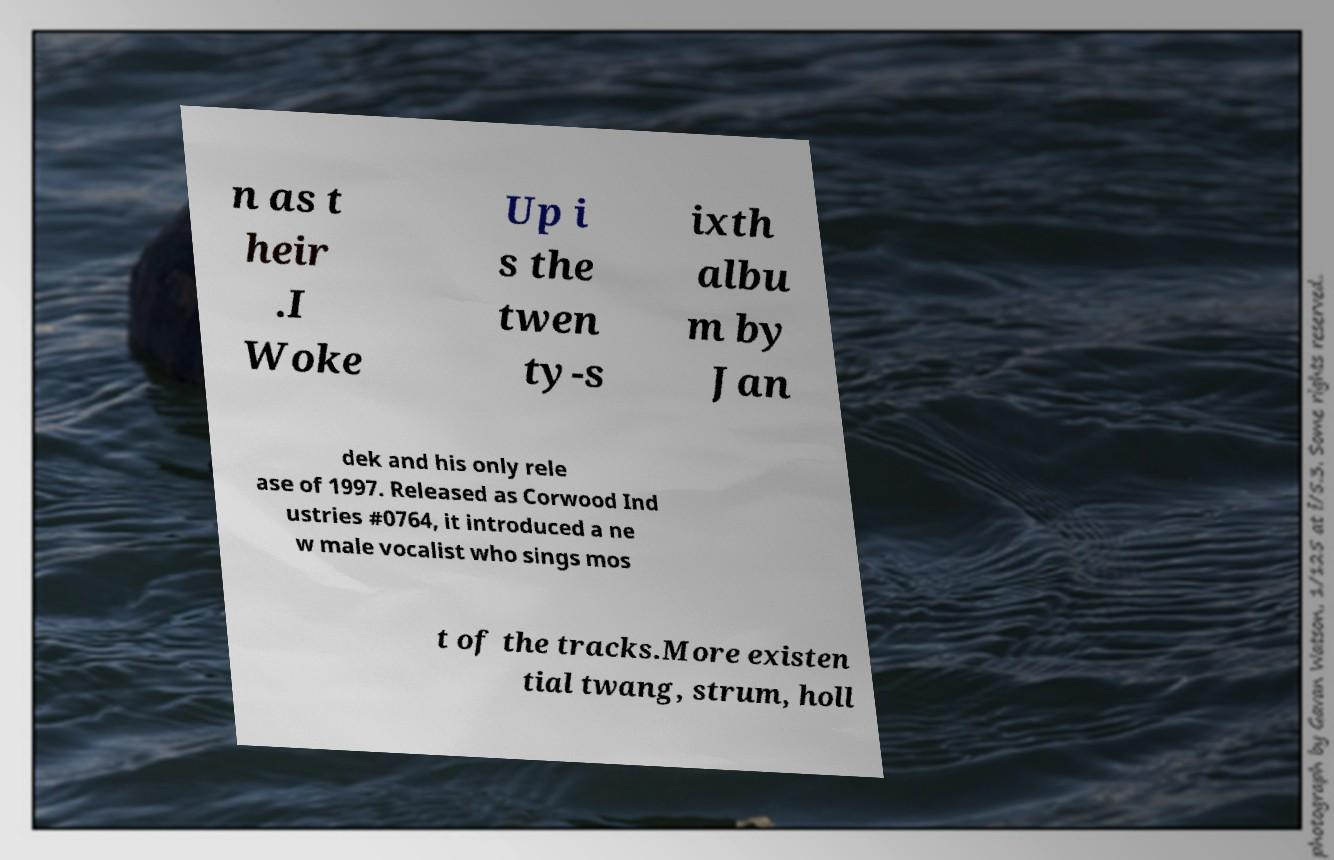Please identify and transcribe the text found in this image. n as t heir .I Woke Up i s the twen ty-s ixth albu m by Jan dek and his only rele ase of 1997. Released as Corwood Ind ustries #0764, it introduced a ne w male vocalist who sings mos t of the tracks.More existen tial twang, strum, holl 